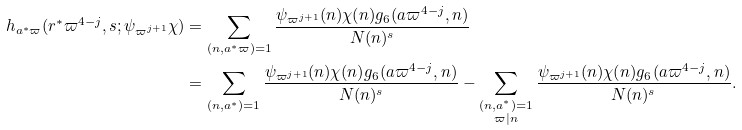Convert formula to latex. <formula><loc_0><loc_0><loc_500><loc_500>h _ { a ^ { * } \varpi } ( r ^ { * } \varpi ^ { 4 - j } , s ; \psi _ { \varpi ^ { j + 1 } } \chi ) & = \sum _ { ( n , a ^ { * } \varpi ) = 1 } \frac { \psi _ { \varpi ^ { j + 1 } } ( n ) \chi ( n ) g _ { 6 } ( a \varpi ^ { 4 - j } , n ) } { N ( n ) ^ { s } } \\ & = \sum _ { ( n , a ^ { * } ) = 1 } \frac { \psi _ { \varpi ^ { j + 1 } } ( n ) \chi ( n ) g _ { 6 } ( a \varpi ^ { 4 - j } , n ) } { N ( n ) ^ { s } } - \sum _ { \substack { ( n , a ^ { * } ) = 1 \\ \varpi | n } } \frac { \psi _ { \varpi ^ { j + 1 } } ( n ) \chi ( n ) g _ { 6 } ( a \varpi ^ { 4 - j } , n ) } { N ( n ) ^ { s } } .</formula> 